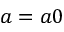<formula> <loc_0><loc_0><loc_500><loc_500>a = a 0</formula> 